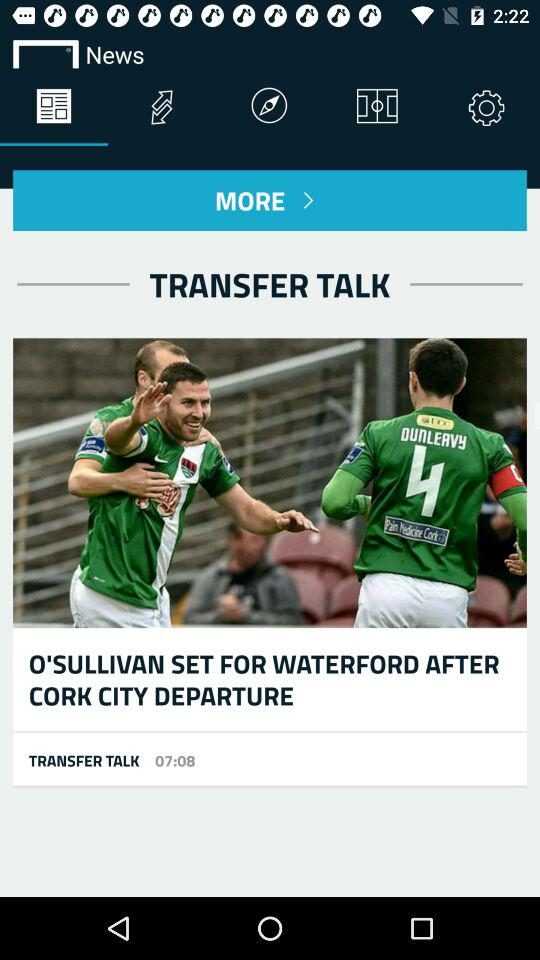How long has O'Sullivan been playing soccer?
When the provided information is insufficient, respond with <no answer>. <no answer> 